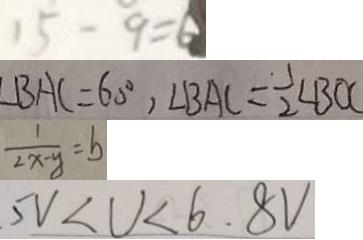<formula> <loc_0><loc_0><loc_500><loc_500>1 5 - 9 = 6 
 \angle B A C = 6 0 ^ { \circ } , \angle B A C = \frac { 1 } { 2 } \angle B O C 
 \frac { 1 } { 2 x - y } = b 
 5 V < U < 6 . 8 V</formula> 